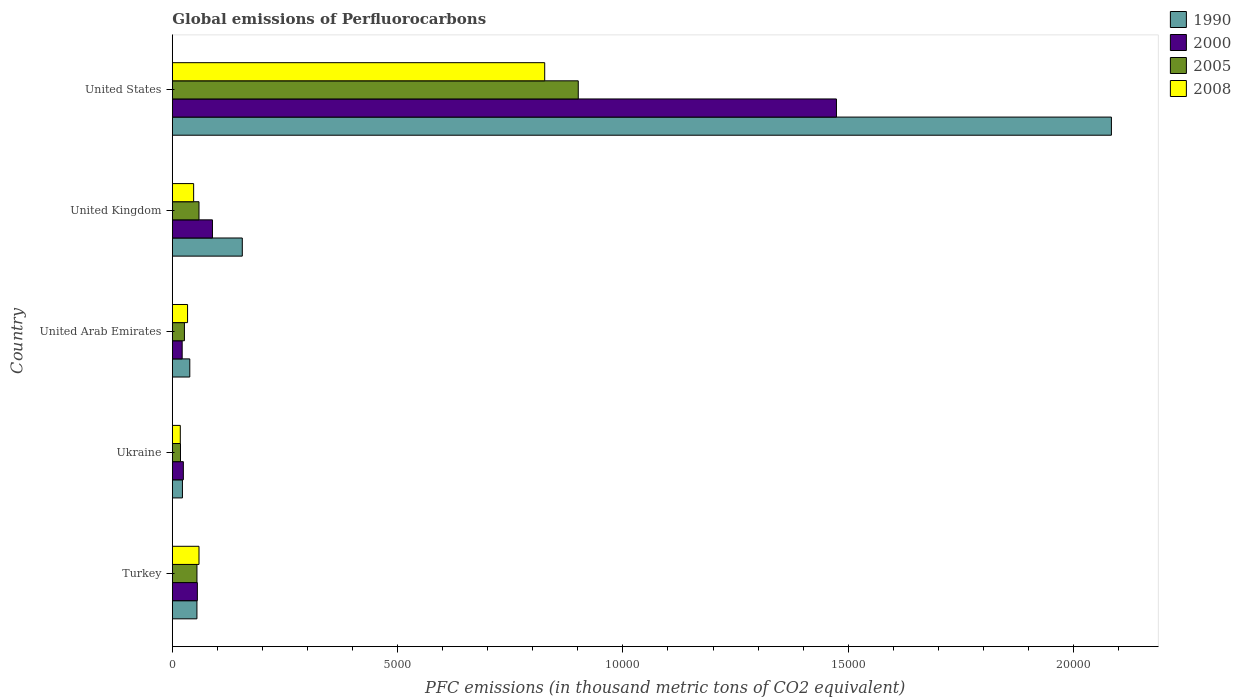How many groups of bars are there?
Your answer should be compact. 5. How many bars are there on the 5th tick from the top?
Provide a short and direct response. 4. What is the label of the 5th group of bars from the top?
Offer a very short reply. Turkey. In how many cases, is the number of bars for a given country not equal to the number of legend labels?
Keep it short and to the point. 0. What is the global emissions of Perfluorocarbons in 2005 in United States?
Provide a succinct answer. 9008.7. Across all countries, what is the maximum global emissions of Perfluorocarbons in 1990?
Ensure brevity in your answer.  2.08e+04. Across all countries, what is the minimum global emissions of Perfluorocarbons in 2008?
Offer a terse response. 176.5. In which country was the global emissions of Perfluorocarbons in 2008 minimum?
Provide a short and direct response. Ukraine. What is the total global emissions of Perfluorocarbons in 2005 in the graph?
Provide a succinct answer. 1.06e+04. What is the difference between the global emissions of Perfluorocarbons in 2008 in Ukraine and that in United Arab Emirates?
Offer a very short reply. -161.1. What is the difference between the global emissions of Perfluorocarbons in 2005 in Turkey and the global emissions of Perfluorocarbons in 1990 in United Arab Emirates?
Make the answer very short. 158.6. What is the average global emissions of Perfluorocarbons in 2000 per country?
Keep it short and to the point. 3329.22. What is the difference between the global emissions of Perfluorocarbons in 2008 and global emissions of Perfluorocarbons in 2000 in United Arab Emirates?
Your answer should be very brief. 119.6. In how many countries, is the global emissions of Perfluorocarbons in 1990 greater than 9000 thousand metric tons?
Ensure brevity in your answer.  1. What is the ratio of the global emissions of Perfluorocarbons in 2000 in Turkey to that in United Arab Emirates?
Keep it short and to the point. 2.55. What is the difference between the highest and the second highest global emissions of Perfluorocarbons in 1990?
Provide a short and direct response. 1.93e+04. What is the difference between the highest and the lowest global emissions of Perfluorocarbons in 2008?
Keep it short and to the point. 8087.5. What does the 1st bar from the top in Turkey represents?
Your answer should be compact. 2008. What is the difference between two consecutive major ticks on the X-axis?
Make the answer very short. 5000. Are the values on the major ticks of X-axis written in scientific E-notation?
Your response must be concise. No. Where does the legend appear in the graph?
Keep it short and to the point. Top right. How many legend labels are there?
Ensure brevity in your answer.  4. How are the legend labels stacked?
Give a very brief answer. Vertical. What is the title of the graph?
Your answer should be compact. Global emissions of Perfluorocarbons. Does "2006" appear as one of the legend labels in the graph?
Keep it short and to the point. No. What is the label or title of the X-axis?
Your answer should be very brief. PFC emissions (in thousand metric tons of CO2 equivalent). What is the label or title of the Y-axis?
Offer a very short reply. Country. What is the PFC emissions (in thousand metric tons of CO2 equivalent) in 1990 in Turkey?
Provide a succinct answer. 545.6. What is the PFC emissions (in thousand metric tons of CO2 equivalent) of 2000 in Turkey?
Offer a very short reply. 554.9. What is the PFC emissions (in thousand metric tons of CO2 equivalent) of 2005 in Turkey?
Your answer should be very brief. 545.9. What is the PFC emissions (in thousand metric tons of CO2 equivalent) of 2008 in Turkey?
Keep it short and to the point. 591.4. What is the PFC emissions (in thousand metric tons of CO2 equivalent) of 1990 in Ukraine?
Your answer should be compact. 224. What is the PFC emissions (in thousand metric tons of CO2 equivalent) in 2000 in Ukraine?
Ensure brevity in your answer.  244.1. What is the PFC emissions (in thousand metric tons of CO2 equivalent) in 2005 in Ukraine?
Provide a short and direct response. 180.5. What is the PFC emissions (in thousand metric tons of CO2 equivalent) in 2008 in Ukraine?
Your answer should be very brief. 176.5. What is the PFC emissions (in thousand metric tons of CO2 equivalent) of 1990 in United Arab Emirates?
Offer a terse response. 387.3. What is the PFC emissions (in thousand metric tons of CO2 equivalent) of 2000 in United Arab Emirates?
Offer a very short reply. 218. What is the PFC emissions (in thousand metric tons of CO2 equivalent) in 2005 in United Arab Emirates?
Give a very brief answer. 267.9. What is the PFC emissions (in thousand metric tons of CO2 equivalent) in 2008 in United Arab Emirates?
Make the answer very short. 337.6. What is the PFC emissions (in thousand metric tons of CO2 equivalent) in 1990 in United Kingdom?
Keep it short and to the point. 1552.5. What is the PFC emissions (in thousand metric tons of CO2 equivalent) of 2000 in United Kingdom?
Provide a short and direct response. 890.1. What is the PFC emissions (in thousand metric tons of CO2 equivalent) in 2005 in United Kingdom?
Offer a terse response. 591.4. What is the PFC emissions (in thousand metric tons of CO2 equivalent) of 2008 in United Kingdom?
Provide a short and direct response. 472.4. What is the PFC emissions (in thousand metric tons of CO2 equivalent) of 1990 in United States?
Keep it short and to the point. 2.08e+04. What is the PFC emissions (in thousand metric tons of CO2 equivalent) in 2000 in United States?
Offer a very short reply. 1.47e+04. What is the PFC emissions (in thousand metric tons of CO2 equivalent) of 2005 in United States?
Give a very brief answer. 9008.7. What is the PFC emissions (in thousand metric tons of CO2 equivalent) of 2008 in United States?
Make the answer very short. 8264. Across all countries, what is the maximum PFC emissions (in thousand metric tons of CO2 equivalent) of 1990?
Your answer should be very brief. 2.08e+04. Across all countries, what is the maximum PFC emissions (in thousand metric tons of CO2 equivalent) in 2000?
Make the answer very short. 1.47e+04. Across all countries, what is the maximum PFC emissions (in thousand metric tons of CO2 equivalent) in 2005?
Provide a succinct answer. 9008.7. Across all countries, what is the maximum PFC emissions (in thousand metric tons of CO2 equivalent) of 2008?
Your answer should be compact. 8264. Across all countries, what is the minimum PFC emissions (in thousand metric tons of CO2 equivalent) in 1990?
Provide a short and direct response. 224. Across all countries, what is the minimum PFC emissions (in thousand metric tons of CO2 equivalent) in 2000?
Offer a terse response. 218. Across all countries, what is the minimum PFC emissions (in thousand metric tons of CO2 equivalent) of 2005?
Your answer should be very brief. 180.5. Across all countries, what is the minimum PFC emissions (in thousand metric tons of CO2 equivalent) of 2008?
Provide a short and direct response. 176.5. What is the total PFC emissions (in thousand metric tons of CO2 equivalent) in 1990 in the graph?
Your answer should be very brief. 2.36e+04. What is the total PFC emissions (in thousand metric tons of CO2 equivalent) in 2000 in the graph?
Make the answer very short. 1.66e+04. What is the total PFC emissions (in thousand metric tons of CO2 equivalent) in 2005 in the graph?
Your answer should be compact. 1.06e+04. What is the total PFC emissions (in thousand metric tons of CO2 equivalent) in 2008 in the graph?
Give a very brief answer. 9841.9. What is the difference between the PFC emissions (in thousand metric tons of CO2 equivalent) in 1990 in Turkey and that in Ukraine?
Make the answer very short. 321.6. What is the difference between the PFC emissions (in thousand metric tons of CO2 equivalent) in 2000 in Turkey and that in Ukraine?
Offer a very short reply. 310.8. What is the difference between the PFC emissions (in thousand metric tons of CO2 equivalent) in 2005 in Turkey and that in Ukraine?
Your answer should be very brief. 365.4. What is the difference between the PFC emissions (in thousand metric tons of CO2 equivalent) in 2008 in Turkey and that in Ukraine?
Keep it short and to the point. 414.9. What is the difference between the PFC emissions (in thousand metric tons of CO2 equivalent) in 1990 in Turkey and that in United Arab Emirates?
Keep it short and to the point. 158.3. What is the difference between the PFC emissions (in thousand metric tons of CO2 equivalent) in 2000 in Turkey and that in United Arab Emirates?
Your answer should be compact. 336.9. What is the difference between the PFC emissions (in thousand metric tons of CO2 equivalent) of 2005 in Turkey and that in United Arab Emirates?
Your answer should be very brief. 278. What is the difference between the PFC emissions (in thousand metric tons of CO2 equivalent) in 2008 in Turkey and that in United Arab Emirates?
Ensure brevity in your answer.  253.8. What is the difference between the PFC emissions (in thousand metric tons of CO2 equivalent) in 1990 in Turkey and that in United Kingdom?
Provide a short and direct response. -1006.9. What is the difference between the PFC emissions (in thousand metric tons of CO2 equivalent) of 2000 in Turkey and that in United Kingdom?
Make the answer very short. -335.2. What is the difference between the PFC emissions (in thousand metric tons of CO2 equivalent) in 2005 in Turkey and that in United Kingdom?
Offer a terse response. -45.5. What is the difference between the PFC emissions (in thousand metric tons of CO2 equivalent) of 2008 in Turkey and that in United Kingdom?
Make the answer very short. 119. What is the difference between the PFC emissions (in thousand metric tons of CO2 equivalent) in 1990 in Turkey and that in United States?
Your response must be concise. -2.03e+04. What is the difference between the PFC emissions (in thousand metric tons of CO2 equivalent) of 2000 in Turkey and that in United States?
Provide a short and direct response. -1.42e+04. What is the difference between the PFC emissions (in thousand metric tons of CO2 equivalent) in 2005 in Turkey and that in United States?
Offer a terse response. -8462.8. What is the difference between the PFC emissions (in thousand metric tons of CO2 equivalent) of 2008 in Turkey and that in United States?
Keep it short and to the point. -7672.6. What is the difference between the PFC emissions (in thousand metric tons of CO2 equivalent) in 1990 in Ukraine and that in United Arab Emirates?
Offer a terse response. -163.3. What is the difference between the PFC emissions (in thousand metric tons of CO2 equivalent) of 2000 in Ukraine and that in United Arab Emirates?
Offer a very short reply. 26.1. What is the difference between the PFC emissions (in thousand metric tons of CO2 equivalent) in 2005 in Ukraine and that in United Arab Emirates?
Ensure brevity in your answer.  -87.4. What is the difference between the PFC emissions (in thousand metric tons of CO2 equivalent) of 2008 in Ukraine and that in United Arab Emirates?
Provide a short and direct response. -161.1. What is the difference between the PFC emissions (in thousand metric tons of CO2 equivalent) of 1990 in Ukraine and that in United Kingdom?
Offer a very short reply. -1328.5. What is the difference between the PFC emissions (in thousand metric tons of CO2 equivalent) of 2000 in Ukraine and that in United Kingdom?
Keep it short and to the point. -646. What is the difference between the PFC emissions (in thousand metric tons of CO2 equivalent) in 2005 in Ukraine and that in United Kingdom?
Your answer should be very brief. -410.9. What is the difference between the PFC emissions (in thousand metric tons of CO2 equivalent) in 2008 in Ukraine and that in United Kingdom?
Give a very brief answer. -295.9. What is the difference between the PFC emissions (in thousand metric tons of CO2 equivalent) of 1990 in Ukraine and that in United States?
Your response must be concise. -2.06e+04. What is the difference between the PFC emissions (in thousand metric tons of CO2 equivalent) of 2000 in Ukraine and that in United States?
Give a very brief answer. -1.45e+04. What is the difference between the PFC emissions (in thousand metric tons of CO2 equivalent) in 2005 in Ukraine and that in United States?
Your response must be concise. -8828.2. What is the difference between the PFC emissions (in thousand metric tons of CO2 equivalent) of 2008 in Ukraine and that in United States?
Your response must be concise. -8087.5. What is the difference between the PFC emissions (in thousand metric tons of CO2 equivalent) of 1990 in United Arab Emirates and that in United Kingdom?
Keep it short and to the point. -1165.2. What is the difference between the PFC emissions (in thousand metric tons of CO2 equivalent) of 2000 in United Arab Emirates and that in United Kingdom?
Ensure brevity in your answer.  -672.1. What is the difference between the PFC emissions (in thousand metric tons of CO2 equivalent) of 2005 in United Arab Emirates and that in United Kingdom?
Offer a terse response. -323.5. What is the difference between the PFC emissions (in thousand metric tons of CO2 equivalent) of 2008 in United Arab Emirates and that in United Kingdom?
Your response must be concise. -134.8. What is the difference between the PFC emissions (in thousand metric tons of CO2 equivalent) in 1990 in United Arab Emirates and that in United States?
Make the answer very short. -2.05e+04. What is the difference between the PFC emissions (in thousand metric tons of CO2 equivalent) in 2000 in United Arab Emirates and that in United States?
Make the answer very short. -1.45e+04. What is the difference between the PFC emissions (in thousand metric tons of CO2 equivalent) in 2005 in United Arab Emirates and that in United States?
Your answer should be compact. -8740.8. What is the difference between the PFC emissions (in thousand metric tons of CO2 equivalent) of 2008 in United Arab Emirates and that in United States?
Offer a very short reply. -7926.4. What is the difference between the PFC emissions (in thousand metric tons of CO2 equivalent) of 1990 in United Kingdom and that in United States?
Keep it short and to the point. -1.93e+04. What is the difference between the PFC emissions (in thousand metric tons of CO2 equivalent) of 2000 in United Kingdom and that in United States?
Ensure brevity in your answer.  -1.38e+04. What is the difference between the PFC emissions (in thousand metric tons of CO2 equivalent) in 2005 in United Kingdom and that in United States?
Your response must be concise. -8417.3. What is the difference between the PFC emissions (in thousand metric tons of CO2 equivalent) of 2008 in United Kingdom and that in United States?
Your answer should be compact. -7791.6. What is the difference between the PFC emissions (in thousand metric tons of CO2 equivalent) of 1990 in Turkey and the PFC emissions (in thousand metric tons of CO2 equivalent) of 2000 in Ukraine?
Keep it short and to the point. 301.5. What is the difference between the PFC emissions (in thousand metric tons of CO2 equivalent) in 1990 in Turkey and the PFC emissions (in thousand metric tons of CO2 equivalent) in 2005 in Ukraine?
Your answer should be compact. 365.1. What is the difference between the PFC emissions (in thousand metric tons of CO2 equivalent) of 1990 in Turkey and the PFC emissions (in thousand metric tons of CO2 equivalent) of 2008 in Ukraine?
Offer a very short reply. 369.1. What is the difference between the PFC emissions (in thousand metric tons of CO2 equivalent) in 2000 in Turkey and the PFC emissions (in thousand metric tons of CO2 equivalent) in 2005 in Ukraine?
Ensure brevity in your answer.  374.4. What is the difference between the PFC emissions (in thousand metric tons of CO2 equivalent) of 2000 in Turkey and the PFC emissions (in thousand metric tons of CO2 equivalent) of 2008 in Ukraine?
Provide a short and direct response. 378.4. What is the difference between the PFC emissions (in thousand metric tons of CO2 equivalent) of 2005 in Turkey and the PFC emissions (in thousand metric tons of CO2 equivalent) of 2008 in Ukraine?
Ensure brevity in your answer.  369.4. What is the difference between the PFC emissions (in thousand metric tons of CO2 equivalent) in 1990 in Turkey and the PFC emissions (in thousand metric tons of CO2 equivalent) in 2000 in United Arab Emirates?
Offer a very short reply. 327.6. What is the difference between the PFC emissions (in thousand metric tons of CO2 equivalent) of 1990 in Turkey and the PFC emissions (in thousand metric tons of CO2 equivalent) of 2005 in United Arab Emirates?
Provide a succinct answer. 277.7. What is the difference between the PFC emissions (in thousand metric tons of CO2 equivalent) of 1990 in Turkey and the PFC emissions (in thousand metric tons of CO2 equivalent) of 2008 in United Arab Emirates?
Make the answer very short. 208. What is the difference between the PFC emissions (in thousand metric tons of CO2 equivalent) of 2000 in Turkey and the PFC emissions (in thousand metric tons of CO2 equivalent) of 2005 in United Arab Emirates?
Provide a short and direct response. 287. What is the difference between the PFC emissions (in thousand metric tons of CO2 equivalent) in 2000 in Turkey and the PFC emissions (in thousand metric tons of CO2 equivalent) in 2008 in United Arab Emirates?
Your answer should be compact. 217.3. What is the difference between the PFC emissions (in thousand metric tons of CO2 equivalent) in 2005 in Turkey and the PFC emissions (in thousand metric tons of CO2 equivalent) in 2008 in United Arab Emirates?
Offer a very short reply. 208.3. What is the difference between the PFC emissions (in thousand metric tons of CO2 equivalent) in 1990 in Turkey and the PFC emissions (in thousand metric tons of CO2 equivalent) in 2000 in United Kingdom?
Your answer should be compact. -344.5. What is the difference between the PFC emissions (in thousand metric tons of CO2 equivalent) in 1990 in Turkey and the PFC emissions (in thousand metric tons of CO2 equivalent) in 2005 in United Kingdom?
Offer a very short reply. -45.8. What is the difference between the PFC emissions (in thousand metric tons of CO2 equivalent) in 1990 in Turkey and the PFC emissions (in thousand metric tons of CO2 equivalent) in 2008 in United Kingdom?
Offer a terse response. 73.2. What is the difference between the PFC emissions (in thousand metric tons of CO2 equivalent) of 2000 in Turkey and the PFC emissions (in thousand metric tons of CO2 equivalent) of 2005 in United Kingdom?
Offer a terse response. -36.5. What is the difference between the PFC emissions (in thousand metric tons of CO2 equivalent) in 2000 in Turkey and the PFC emissions (in thousand metric tons of CO2 equivalent) in 2008 in United Kingdom?
Your answer should be very brief. 82.5. What is the difference between the PFC emissions (in thousand metric tons of CO2 equivalent) in 2005 in Turkey and the PFC emissions (in thousand metric tons of CO2 equivalent) in 2008 in United Kingdom?
Ensure brevity in your answer.  73.5. What is the difference between the PFC emissions (in thousand metric tons of CO2 equivalent) of 1990 in Turkey and the PFC emissions (in thousand metric tons of CO2 equivalent) of 2000 in United States?
Keep it short and to the point. -1.42e+04. What is the difference between the PFC emissions (in thousand metric tons of CO2 equivalent) of 1990 in Turkey and the PFC emissions (in thousand metric tons of CO2 equivalent) of 2005 in United States?
Make the answer very short. -8463.1. What is the difference between the PFC emissions (in thousand metric tons of CO2 equivalent) in 1990 in Turkey and the PFC emissions (in thousand metric tons of CO2 equivalent) in 2008 in United States?
Keep it short and to the point. -7718.4. What is the difference between the PFC emissions (in thousand metric tons of CO2 equivalent) in 2000 in Turkey and the PFC emissions (in thousand metric tons of CO2 equivalent) in 2005 in United States?
Your answer should be very brief. -8453.8. What is the difference between the PFC emissions (in thousand metric tons of CO2 equivalent) in 2000 in Turkey and the PFC emissions (in thousand metric tons of CO2 equivalent) in 2008 in United States?
Your response must be concise. -7709.1. What is the difference between the PFC emissions (in thousand metric tons of CO2 equivalent) in 2005 in Turkey and the PFC emissions (in thousand metric tons of CO2 equivalent) in 2008 in United States?
Offer a very short reply. -7718.1. What is the difference between the PFC emissions (in thousand metric tons of CO2 equivalent) in 1990 in Ukraine and the PFC emissions (in thousand metric tons of CO2 equivalent) in 2000 in United Arab Emirates?
Make the answer very short. 6. What is the difference between the PFC emissions (in thousand metric tons of CO2 equivalent) of 1990 in Ukraine and the PFC emissions (in thousand metric tons of CO2 equivalent) of 2005 in United Arab Emirates?
Keep it short and to the point. -43.9. What is the difference between the PFC emissions (in thousand metric tons of CO2 equivalent) of 1990 in Ukraine and the PFC emissions (in thousand metric tons of CO2 equivalent) of 2008 in United Arab Emirates?
Your response must be concise. -113.6. What is the difference between the PFC emissions (in thousand metric tons of CO2 equivalent) of 2000 in Ukraine and the PFC emissions (in thousand metric tons of CO2 equivalent) of 2005 in United Arab Emirates?
Your answer should be compact. -23.8. What is the difference between the PFC emissions (in thousand metric tons of CO2 equivalent) in 2000 in Ukraine and the PFC emissions (in thousand metric tons of CO2 equivalent) in 2008 in United Arab Emirates?
Your response must be concise. -93.5. What is the difference between the PFC emissions (in thousand metric tons of CO2 equivalent) in 2005 in Ukraine and the PFC emissions (in thousand metric tons of CO2 equivalent) in 2008 in United Arab Emirates?
Offer a terse response. -157.1. What is the difference between the PFC emissions (in thousand metric tons of CO2 equivalent) of 1990 in Ukraine and the PFC emissions (in thousand metric tons of CO2 equivalent) of 2000 in United Kingdom?
Ensure brevity in your answer.  -666.1. What is the difference between the PFC emissions (in thousand metric tons of CO2 equivalent) of 1990 in Ukraine and the PFC emissions (in thousand metric tons of CO2 equivalent) of 2005 in United Kingdom?
Ensure brevity in your answer.  -367.4. What is the difference between the PFC emissions (in thousand metric tons of CO2 equivalent) in 1990 in Ukraine and the PFC emissions (in thousand metric tons of CO2 equivalent) in 2008 in United Kingdom?
Your answer should be very brief. -248.4. What is the difference between the PFC emissions (in thousand metric tons of CO2 equivalent) in 2000 in Ukraine and the PFC emissions (in thousand metric tons of CO2 equivalent) in 2005 in United Kingdom?
Make the answer very short. -347.3. What is the difference between the PFC emissions (in thousand metric tons of CO2 equivalent) in 2000 in Ukraine and the PFC emissions (in thousand metric tons of CO2 equivalent) in 2008 in United Kingdom?
Make the answer very short. -228.3. What is the difference between the PFC emissions (in thousand metric tons of CO2 equivalent) in 2005 in Ukraine and the PFC emissions (in thousand metric tons of CO2 equivalent) in 2008 in United Kingdom?
Your answer should be very brief. -291.9. What is the difference between the PFC emissions (in thousand metric tons of CO2 equivalent) in 1990 in Ukraine and the PFC emissions (in thousand metric tons of CO2 equivalent) in 2000 in United States?
Your response must be concise. -1.45e+04. What is the difference between the PFC emissions (in thousand metric tons of CO2 equivalent) in 1990 in Ukraine and the PFC emissions (in thousand metric tons of CO2 equivalent) in 2005 in United States?
Offer a terse response. -8784.7. What is the difference between the PFC emissions (in thousand metric tons of CO2 equivalent) in 1990 in Ukraine and the PFC emissions (in thousand metric tons of CO2 equivalent) in 2008 in United States?
Offer a terse response. -8040. What is the difference between the PFC emissions (in thousand metric tons of CO2 equivalent) of 2000 in Ukraine and the PFC emissions (in thousand metric tons of CO2 equivalent) of 2005 in United States?
Ensure brevity in your answer.  -8764.6. What is the difference between the PFC emissions (in thousand metric tons of CO2 equivalent) of 2000 in Ukraine and the PFC emissions (in thousand metric tons of CO2 equivalent) of 2008 in United States?
Offer a very short reply. -8019.9. What is the difference between the PFC emissions (in thousand metric tons of CO2 equivalent) in 2005 in Ukraine and the PFC emissions (in thousand metric tons of CO2 equivalent) in 2008 in United States?
Ensure brevity in your answer.  -8083.5. What is the difference between the PFC emissions (in thousand metric tons of CO2 equivalent) in 1990 in United Arab Emirates and the PFC emissions (in thousand metric tons of CO2 equivalent) in 2000 in United Kingdom?
Ensure brevity in your answer.  -502.8. What is the difference between the PFC emissions (in thousand metric tons of CO2 equivalent) of 1990 in United Arab Emirates and the PFC emissions (in thousand metric tons of CO2 equivalent) of 2005 in United Kingdom?
Offer a very short reply. -204.1. What is the difference between the PFC emissions (in thousand metric tons of CO2 equivalent) of 1990 in United Arab Emirates and the PFC emissions (in thousand metric tons of CO2 equivalent) of 2008 in United Kingdom?
Provide a short and direct response. -85.1. What is the difference between the PFC emissions (in thousand metric tons of CO2 equivalent) of 2000 in United Arab Emirates and the PFC emissions (in thousand metric tons of CO2 equivalent) of 2005 in United Kingdom?
Provide a short and direct response. -373.4. What is the difference between the PFC emissions (in thousand metric tons of CO2 equivalent) of 2000 in United Arab Emirates and the PFC emissions (in thousand metric tons of CO2 equivalent) of 2008 in United Kingdom?
Keep it short and to the point. -254.4. What is the difference between the PFC emissions (in thousand metric tons of CO2 equivalent) of 2005 in United Arab Emirates and the PFC emissions (in thousand metric tons of CO2 equivalent) of 2008 in United Kingdom?
Your answer should be compact. -204.5. What is the difference between the PFC emissions (in thousand metric tons of CO2 equivalent) in 1990 in United Arab Emirates and the PFC emissions (in thousand metric tons of CO2 equivalent) in 2000 in United States?
Provide a short and direct response. -1.44e+04. What is the difference between the PFC emissions (in thousand metric tons of CO2 equivalent) in 1990 in United Arab Emirates and the PFC emissions (in thousand metric tons of CO2 equivalent) in 2005 in United States?
Provide a short and direct response. -8621.4. What is the difference between the PFC emissions (in thousand metric tons of CO2 equivalent) in 1990 in United Arab Emirates and the PFC emissions (in thousand metric tons of CO2 equivalent) in 2008 in United States?
Make the answer very short. -7876.7. What is the difference between the PFC emissions (in thousand metric tons of CO2 equivalent) in 2000 in United Arab Emirates and the PFC emissions (in thousand metric tons of CO2 equivalent) in 2005 in United States?
Keep it short and to the point. -8790.7. What is the difference between the PFC emissions (in thousand metric tons of CO2 equivalent) of 2000 in United Arab Emirates and the PFC emissions (in thousand metric tons of CO2 equivalent) of 2008 in United States?
Keep it short and to the point. -8046. What is the difference between the PFC emissions (in thousand metric tons of CO2 equivalent) of 2005 in United Arab Emirates and the PFC emissions (in thousand metric tons of CO2 equivalent) of 2008 in United States?
Your answer should be very brief. -7996.1. What is the difference between the PFC emissions (in thousand metric tons of CO2 equivalent) of 1990 in United Kingdom and the PFC emissions (in thousand metric tons of CO2 equivalent) of 2000 in United States?
Make the answer very short. -1.32e+04. What is the difference between the PFC emissions (in thousand metric tons of CO2 equivalent) in 1990 in United Kingdom and the PFC emissions (in thousand metric tons of CO2 equivalent) in 2005 in United States?
Give a very brief answer. -7456.2. What is the difference between the PFC emissions (in thousand metric tons of CO2 equivalent) in 1990 in United Kingdom and the PFC emissions (in thousand metric tons of CO2 equivalent) in 2008 in United States?
Offer a terse response. -6711.5. What is the difference between the PFC emissions (in thousand metric tons of CO2 equivalent) of 2000 in United Kingdom and the PFC emissions (in thousand metric tons of CO2 equivalent) of 2005 in United States?
Offer a terse response. -8118.6. What is the difference between the PFC emissions (in thousand metric tons of CO2 equivalent) of 2000 in United Kingdom and the PFC emissions (in thousand metric tons of CO2 equivalent) of 2008 in United States?
Your answer should be very brief. -7373.9. What is the difference between the PFC emissions (in thousand metric tons of CO2 equivalent) in 2005 in United Kingdom and the PFC emissions (in thousand metric tons of CO2 equivalent) in 2008 in United States?
Offer a very short reply. -7672.6. What is the average PFC emissions (in thousand metric tons of CO2 equivalent) in 1990 per country?
Make the answer very short. 4710.14. What is the average PFC emissions (in thousand metric tons of CO2 equivalent) of 2000 per country?
Give a very brief answer. 3329.22. What is the average PFC emissions (in thousand metric tons of CO2 equivalent) in 2005 per country?
Make the answer very short. 2118.88. What is the average PFC emissions (in thousand metric tons of CO2 equivalent) of 2008 per country?
Offer a terse response. 1968.38. What is the difference between the PFC emissions (in thousand metric tons of CO2 equivalent) in 1990 and PFC emissions (in thousand metric tons of CO2 equivalent) in 2005 in Turkey?
Offer a very short reply. -0.3. What is the difference between the PFC emissions (in thousand metric tons of CO2 equivalent) of 1990 and PFC emissions (in thousand metric tons of CO2 equivalent) of 2008 in Turkey?
Keep it short and to the point. -45.8. What is the difference between the PFC emissions (in thousand metric tons of CO2 equivalent) in 2000 and PFC emissions (in thousand metric tons of CO2 equivalent) in 2005 in Turkey?
Your answer should be very brief. 9. What is the difference between the PFC emissions (in thousand metric tons of CO2 equivalent) in 2000 and PFC emissions (in thousand metric tons of CO2 equivalent) in 2008 in Turkey?
Your response must be concise. -36.5. What is the difference between the PFC emissions (in thousand metric tons of CO2 equivalent) in 2005 and PFC emissions (in thousand metric tons of CO2 equivalent) in 2008 in Turkey?
Your answer should be very brief. -45.5. What is the difference between the PFC emissions (in thousand metric tons of CO2 equivalent) of 1990 and PFC emissions (in thousand metric tons of CO2 equivalent) of 2000 in Ukraine?
Your answer should be very brief. -20.1. What is the difference between the PFC emissions (in thousand metric tons of CO2 equivalent) in 1990 and PFC emissions (in thousand metric tons of CO2 equivalent) in 2005 in Ukraine?
Make the answer very short. 43.5. What is the difference between the PFC emissions (in thousand metric tons of CO2 equivalent) of 1990 and PFC emissions (in thousand metric tons of CO2 equivalent) of 2008 in Ukraine?
Ensure brevity in your answer.  47.5. What is the difference between the PFC emissions (in thousand metric tons of CO2 equivalent) of 2000 and PFC emissions (in thousand metric tons of CO2 equivalent) of 2005 in Ukraine?
Offer a very short reply. 63.6. What is the difference between the PFC emissions (in thousand metric tons of CO2 equivalent) in 2000 and PFC emissions (in thousand metric tons of CO2 equivalent) in 2008 in Ukraine?
Offer a very short reply. 67.6. What is the difference between the PFC emissions (in thousand metric tons of CO2 equivalent) in 2005 and PFC emissions (in thousand metric tons of CO2 equivalent) in 2008 in Ukraine?
Keep it short and to the point. 4. What is the difference between the PFC emissions (in thousand metric tons of CO2 equivalent) of 1990 and PFC emissions (in thousand metric tons of CO2 equivalent) of 2000 in United Arab Emirates?
Provide a succinct answer. 169.3. What is the difference between the PFC emissions (in thousand metric tons of CO2 equivalent) of 1990 and PFC emissions (in thousand metric tons of CO2 equivalent) of 2005 in United Arab Emirates?
Keep it short and to the point. 119.4. What is the difference between the PFC emissions (in thousand metric tons of CO2 equivalent) in 1990 and PFC emissions (in thousand metric tons of CO2 equivalent) in 2008 in United Arab Emirates?
Offer a terse response. 49.7. What is the difference between the PFC emissions (in thousand metric tons of CO2 equivalent) of 2000 and PFC emissions (in thousand metric tons of CO2 equivalent) of 2005 in United Arab Emirates?
Provide a short and direct response. -49.9. What is the difference between the PFC emissions (in thousand metric tons of CO2 equivalent) in 2000 and PFC emissions (in thousand metric tons of CO2 equivalent) in 2008 in United Arab Emirates?
Make the answer very short. -119.6. What is the difference between the PFC emissions (in thousand metric tons of CO2 equivalent) in 2005 and PFC emissions (in thousand metric tons of CO2 equivalent) in 2008 in United Arab Emirates?
Provide a succinct answer. -69.7. What is the difference between the PFC emissions (in thousand metric tons of CO2 equivalent) of 1990 and PFC emissions (in thousand metric tons of CO2 equivalent) of 2000 in United Kingdom?
Provide a succinct answer. 662.4. What is the difference between the PFC emissions (in thousand metric tons of CO2 equivalent) of 1990 and PFC emissions (in thousand metric tons of CO2 equivalent) of 2005 in United Kingdom?
Keep it short and to the point. 961.1. What is the difference between the PFC emissions (in thousand metric tons of CO2 equivalent) of 1990 and PFC emissions (in thousand metric tons of CO2 equivalent) of 2008 in United Kingdom?
Make the answer very short. 1080.1. What is the difference between the PFC emissions (in thousand metric tons of CO2 equivalent) of 2000 and PFC emissions (in thousand metric tons of CO2 equivalent) of 2005 in United Kingdom?
Your response must be concise. 298.7. What is the difference between the PFC emissions (in thousand metric tons of CO2 equivalent) in 2000 and PFC emissions (in thousand metric tons of CO2 equivalent) in 2008 in United Kingdom?
Offer a terse response. 417.7. What is the difference between the PFC emissions (in thousand metric tons of CO2 equivalent) in 2005 and PFC emissions (in thousand metric tons of CO2 equivalent) in 2008 in United Kingdom?
Offer a terse response. 119. What is the difference between the PFC emissions (in thousand metric tons of CO2 equivalent) of 1990 and PFC emissions (in thousand metric tons of CO2 equivalent) of 2000 in United States?
Offer a terse response. 6102.3. What is the difference between the PFC emissions (in thousand metric tons of CO2 equivalent) of 1990 and PFC emissions (in thousand metric tons of CO2 equivalent) of 2005 in United States?
Offer a terse response. 1.18e+04. What is the difference between the PFC emissions (in thousand metric tons of CO2 equivalent) of 1990 and PFC emissions (in thousand metric tons of CO2 equivalent) of 2008 in United States?
Your answer should be compact. 1.26e+04. What is the difference between the PFC emissions (in thousand metric tons of CO2 equivalent) in 2000 and PFC emissions (in thousand metric tons of CO2 equivalent) in 2005 in United States?
Provide a succinct answer. 5730.3. What is the difference between the PFC emissions (in thousand metric tons of CO2 equivalent) of 2000 and PFC emissions (in thousand metric tons of CO2 equivalent) of 2008 in United States?
Offer a very short reply. 6475. What is the difference between the PFC emissions (in thousand metric tons of CO2 equivalent) in 2005 and PFC emissions (in thousand metric tons of CO2 equivalent) in 2008 in United States?
Provide a succinct answer. 744.7. What is the ratio of the PFC emissions (in thousand metric tons of CO2 equivalent) of 1990 in Turkey to that in Ukraine?
Give a very brief answer. 2.44. What is the ratio of the PFC emissions (in thousand metric tons of CO2 equivalent) of 2000 in Turkey to that in Ukraine?
Your answer should be compact. 2.27. What is the ratio of the PFC emissions (in thousand metric tons of CO2 equivalent) in 2005 in Turkey to that in Ukraine?
Offer a terse response. 3.02. What is the ratio of the PFC emissions (in thousand metric tons of CO2 equivalent) of 2008 in Turkey to that in Ukraine?
Offer a terse response. 3.35. What is the ratio of the PFC emissions (in thousand metric tons of CO2 equivalent) in 1990 in Turkey to that in United Arab Emirates?
Give a very brief answer. 1.41. What is the ratio of the PFC emissions (in thousand metric tons of CO2 equivalent) of 2000 in Turkey to that in United Arab Emirates?
Offer a terse response. 2.55. What is the ratio of the PFC emissions (in thousand metric tons of CO2 equivalent) in 2005 in Turkey to that in United Arab Emirates?
Provide a succinct answer. 2.04. What is the ratio of the PFC emissions (in thousand metric tons of CO2 equivalent) of 2008 in Turkey to that in United Arab Emirates?
Provide a short and direct response. 1.75. What is the ratio of the PFC emissions (in thousand metric tons of CO2 equivalent) of 1990 in Turkey to that in United Kingdom?
Keep it short and to the point. 0.35. What is the ratio of the PFC emissions (in thousand metric tons of CO2 equivalent) of 2000 in Turkey to that in United Kingdom?
Keep it short and to the point. 0.62. What is the ratio of the PFC emissions (in thousand metric tons of CO2 equivalent) of 2005 in Turkey to that in United Kingdom?
Provide a short and direct response. 0.92. What is the ratio of the PFC emissions (in thousand metric tons of CO2 equivalent) in 2008 in Turkey to that in United Kingdom?
Offer a terse response. 1.25. What is the ratio of the PFC emissions (in thousand metric tons of CO2 equivalent) in 1990 in Turkey to that in United States?
Offer a very short reply. 0.03. What is the ratio of the PFC emissions (in thousand metric tons of CO2 equivalent) in 2000 in Turkey to that in United States?
Keep it short and to the point. 0.04. What is the ratio of the PFC emissions (in thousand metric tons of CO2 equivalent) in 2005 in Turkey to that in United States?
Provide a short and direct response. 0.06. What is the ratio of the PFC emissions (in thousand metric tons of CO2 equivalent) in 2008 in Turkey to that in United States?
Ensure brevity in your answer.  0.07. What is the ratio of the PFC emissions (in thousand metric tons of CO2 equivalent) in 1990 in Ukraine to that in United Arab Emirates?
Your answer should be compact. 0.58. What is the ratio of the PFC emissions (in thousand metric tons of CO2 equivalent) in 2000 in Ukraine to that in United Arab Emirates?
Ensure brevity in your answer.  1.12. What is the ratio of the PFC emissions (in thousand metric tons of CO2 equivalent) of 2005 in Ukraine to that in United Arab Emirates?
Keep it short and to the point. 0.67. What is the ratio of the PFC emissions (in thousand metric tons of CO2 equivalent) of 2008 in Ukraine to that in United Arab Emirates?
Offer a very short reply. 0.52. What is the ratio of the PFC emissions (in thousand metric tons of CO2 equivalent) of 1990 in Ukraine to that in United Kingdom?
Your response must be concise. 0.14. What is the ratio of the PFC emissions (in thousand metric tons of CO2 equivalent) in 2000 in Ukraine to that in United Kingdom?
Ensure brevity in your answer.  0.27. What is the ratio of the PFC emissions (in thousand metric tons of CO2 equivalent) in 2005 in Ukraine to that in United Kingdom?
Your answer should be compact. 0.31. What is the ratio of the PFC emissions (in thousand metric tons of CO2 equivalent) in 2008 in Ukraine to that in United Kingdom?
Provide a short and direct response. 0.37. What is the ratio of the PFC emissions (in thousand metric tons of CO2 equivalent) of 1990 in Ukraine to that in United States?
Your answer should be very brief. 0.01. What is the ratio of the PFC emissions (in thousand metric tons of CO2 equivalent) of 2000 in Ukraine to that in United States?
Your answer should be very brief. 0.02. What is the ratio of the PFC emissions (in thousand metric tons of CO2 equivalent) of 2005 in Ukraine to that in United States?
Your answer should be very brief. 0.02. What is the ratio of the PFC emissions (in thousand metric tons of CO2 equivalent) of 2008 in Ukraine to that in United States?
Provide a short and direct response. 0.02. What is the ratio of the PFC emissions (in thousand metric tons of CO2 equivalent) in 1990 in United Arab Emirates to that in United Kingdom?
Your response must be concise. 0.25. What is the ratio of the PFC emissions (in thousand metric tons of CO2 equivalent) in 2000 in United Arab Emirates to that in United Kingdom?
Provide a short and direct response. 0.24. What is the ratio of the PFC emissions (in thousand metric tons of CO2 equivalent) of 2005 in United Arab Emirates to that in United Kingdom?
Provide a succinct answer. 0.45. What is the ratio of the PFC emissions (in thousand metric tons of CO2 equivalent) in 2008 in United Arab Emirates to that in United Kingdom?
Your response must be concise. 0.71. What is the ratio of the PFC emissions (in thousand metric tons of CO2 equivalent) of 1990 in United Arab Emirates to that in United States?
Make the answer very short. 0.02. What is the ratio of the PFC emissions (in thousand metric tons of CO2 equivalent) in 2000 in United Arab Emirates to that in United States?
Your response must be concise. 0.01. What is the ratio of the PFC emissions (in thousand metric tons of CO2 equivalent) in 2005 in United Arab Emirates to that in United States?
Your answer should be very brief. 0.03. What is the ratio of the PFC emissions (in thousand metric tons of CO2 equivalent) in 2008 in United Arab Emirates to that in United States?
Provide a succinct answer. 0.04. What is the ratio of the PFC emissions (in thousand metric tons of CO2 equivalent) in 1990 in United Kingdom to that in United States?
Your response must be concise. 0.07. What is the ratio of the PFC emissions (in thousand metric tons of CO2 equivalent) in 2000 in United Kingdom to that in United States?
Your answer should be compact. 0.06. What is the ratio of the PFC emissions (in thousand metric tons of CO2 equivalent) in 2005 in United Kingdom to that in United States?
Offer a very short reply. 0.07. What is the ratio of the PFC emissions (in thousand metric tons of CO2 equivalent) of 2008 in United Kingdom to that in United States?
Provide a short and direct response. 0.06. What is the difference between the highest and the second highest PFC emissions (in thousand metric tons of CO2 equivalent) of 1990?
Your answer should be compact. 1.93e+04. What is the difference between the highest and the second highest PFC emissions (in thousand metric tons of CO2 equivalent) of 2000?
Provide a short and direct response. 1.38e+04. What is the difference between the highest and the second highest PFC emissions (in thousand metric tons of CO2 equivalent) in 2005?
Your response must be concise. 8417.3. What is the difference between the highest and the second highest PFC emissions (in thousand metric tons of CO2 equivalent) in 2008?
Provide a short and direct response. 7672.6. What is the difference between the highest and the lowest PFC emissions (in thousand metric tons of CO2 equivalent) in 1990?
Ensure brevity in your answer.  2.06e+04. What is the difference between the highest and the lowest PFC emissions (in thousand metric tons of CO2 equivalent) of 2000?
Your response must be concise. 1.45e+04. What is the difference between the highest and the lowest PFC emissions (in thousand metric tons of CO2 equivalent) of 2005?
Your answer should be very brief. 8828.2. What is the difference between the highest and the lowest PFC emissions (in thousand metric tons of CO2 equivalent) in 2008?
Offer a very short reply. 8087.5. 